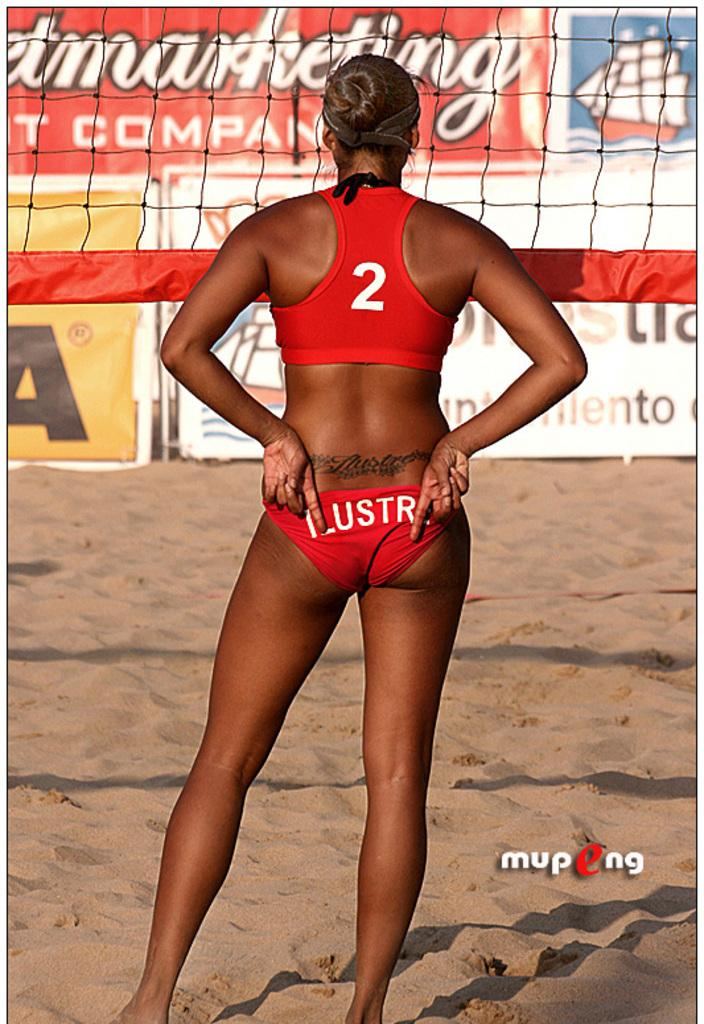<image>
Share a concise interpretation of the image provided. A woman standing in front of a volleyball net wearing a bikini with a 2 on the back. 